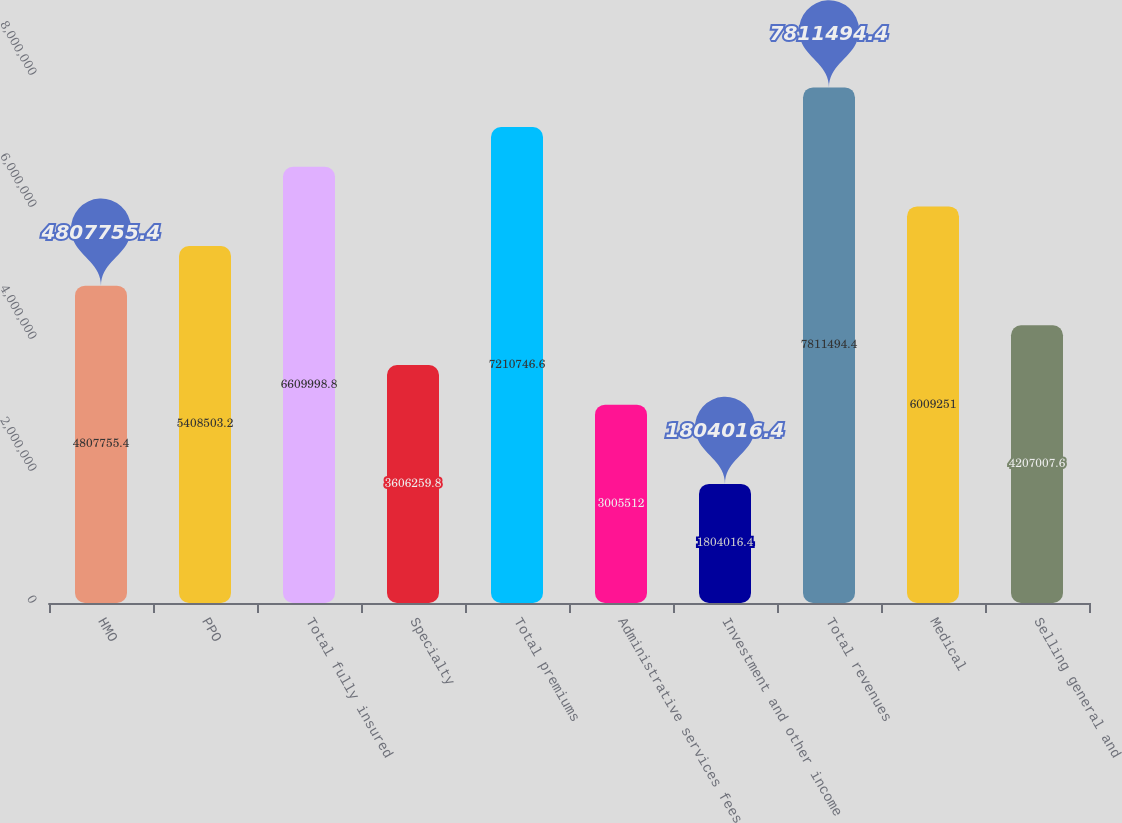Convert chart. <chart><loc_0><loc_0><loc_500><loc_500><bar_chart><fcel>HMO<fcel>PPO<fcel>Total fully insured<fcel>Specialty<fcel>Total premiums<fcel>Administrative services fees<fcel>Investment and other income<fcel>Total revenues<fcel>Medical<fcel>Selling general and<nl><fcel>4.80776e+06<fcel>5.4085e+06<fcel>6.61e+06<fcel>3.60626e+06<fcel>7.21075e+06<fcel>3.00551e+06<fcel>1.80402e+06<fcel>7.81149e+06<fcel>6.00925e+06<fcel>4.20701e+06<nl></chart> 